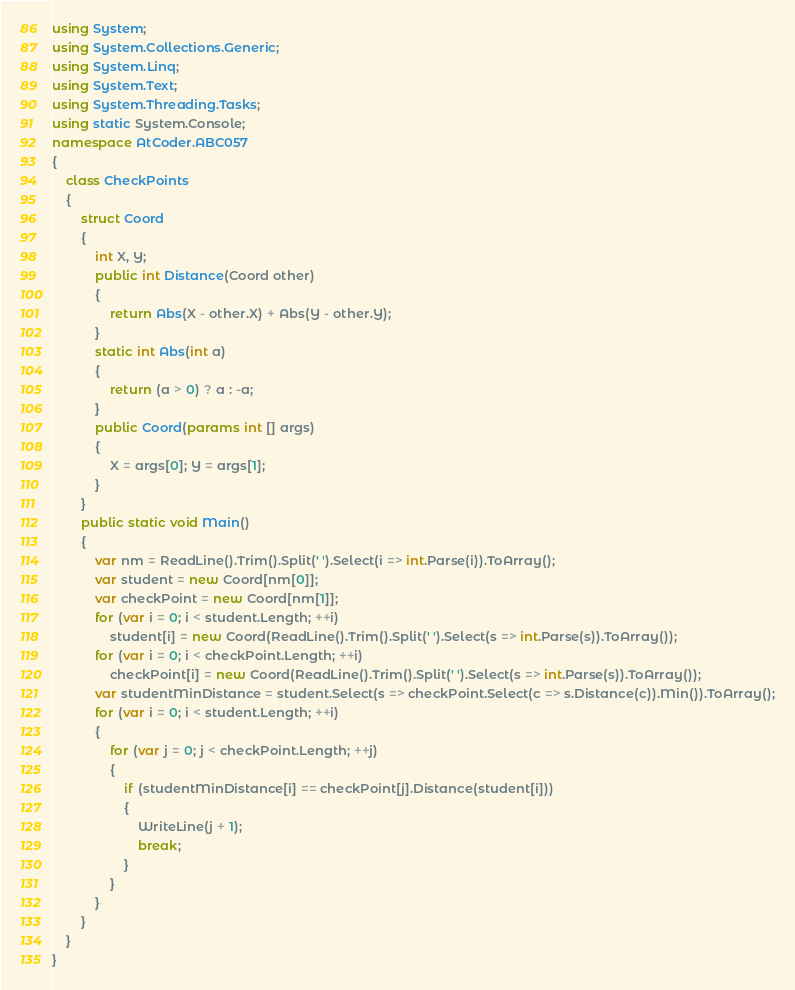Convert code to text. <code><loc_0><loc_0><loc_500><loc_500><_C#_>using System;
using System.Collections.Generic;
using System.Linq;
using System.Text;
using System.Threading.Tasks;
using static System.Console;
namespace AtCoder.ABC057
{
    class CheckPoints
    {
        struct Coord
        {
            int X, Y;
            public int Distance(Coord other)
            {
                return Abs(X - other.X) + Abs(Y - other.Y);
            }
            static int Abs(int a)
            {
                return (a > 0) ? a : -a;
            }
            public Coord(params int [] args)
            {
                X = args[0]; Y = args[1];
            }
        }
        public static void Main()
        {
            var nm = ReadLine().Trim().Split(' ').Select(i => int.Parse(i)).ToArray();
            var student = new Coord[nm[0]];
            var checkPoint = new Coord[nm[1]];
            for (var i = 0; i < student.Length; ++i)
                student[i] = new Coord(ReadLine().Trim().Split(' ').Select(s => int.Parse(s)).ToArray());
            for (var i = 0; i < checkPoint.Length; ++i)
                checkPoint[i] = new Coord(ReadLine().Trim().Split(' ').Select(s => int.Parse(s)).ToArray());
            var studentMinDistance = student.Select(s => checkPoint.Select(c => s.Distance(c)).Min()).ToArray();
            for (var i = 0; i < student.Length; ++i)
            {
                for (var j = 0; j < checkPoint.Length; ++j)
                {
                    if (studentMinDistance[i] == checkPoint[j].Distance(student[i]))
                    {
                        WriteLine(j + 1);
                        break;
                    }
                }
            }
        }
    }
}
</code> 